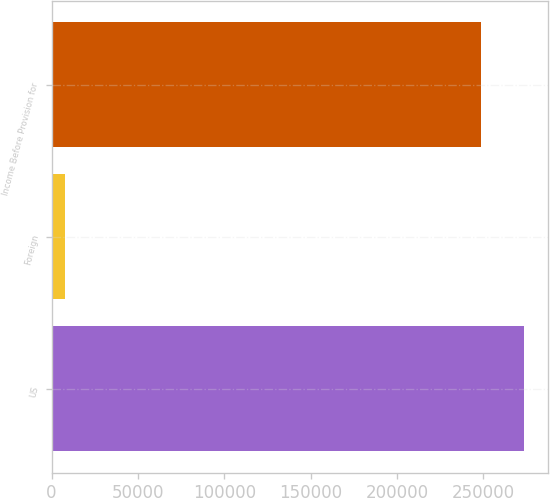<chart> <loc_0><loc_0><loc_500><loc_500><bar_chart><fcel>US<fcel>Foreign<fcel>Income Before Provision for<nl><fcel>273651<fcel>7885<fcel>248774<nl></chart> 